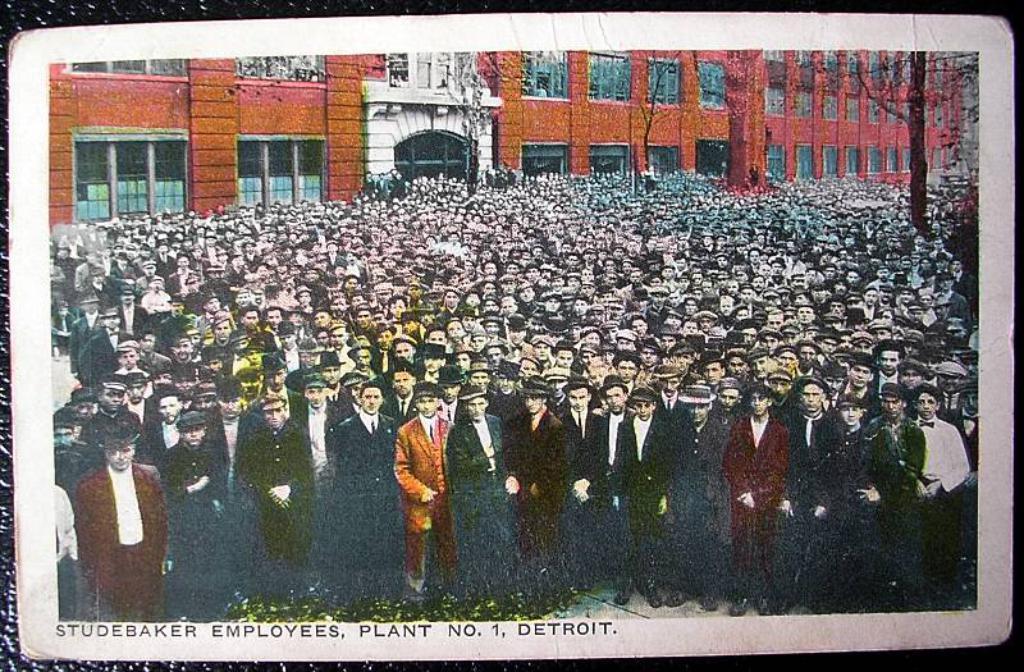Can you describe this image briefly? This is a photo frame in this image in the center there are a group of people who are standing, and in the background there is a building and trees and at the bottom of the image there is some text. 